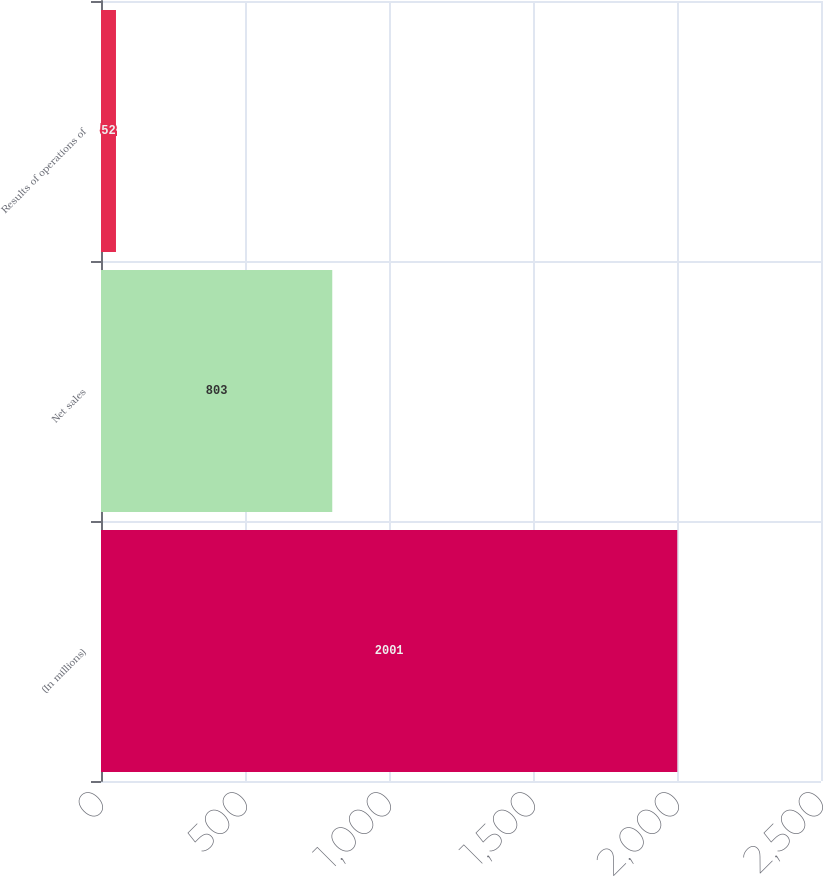Convert chart to OTSL. <chart><loc_0><loc_0><loc_500><loc_500><bar_chart><fcel>(In millions)<fcel>Net sales<fcel>Results of operations of<nl><fcel>2001<fcel>803<fcel>52<nl></chart> 